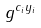Convert formula to latex. <formula><loc_0><loc_0><loc_500><loc_500>g ^ { c _ { i } y _ { i } }</formula> 